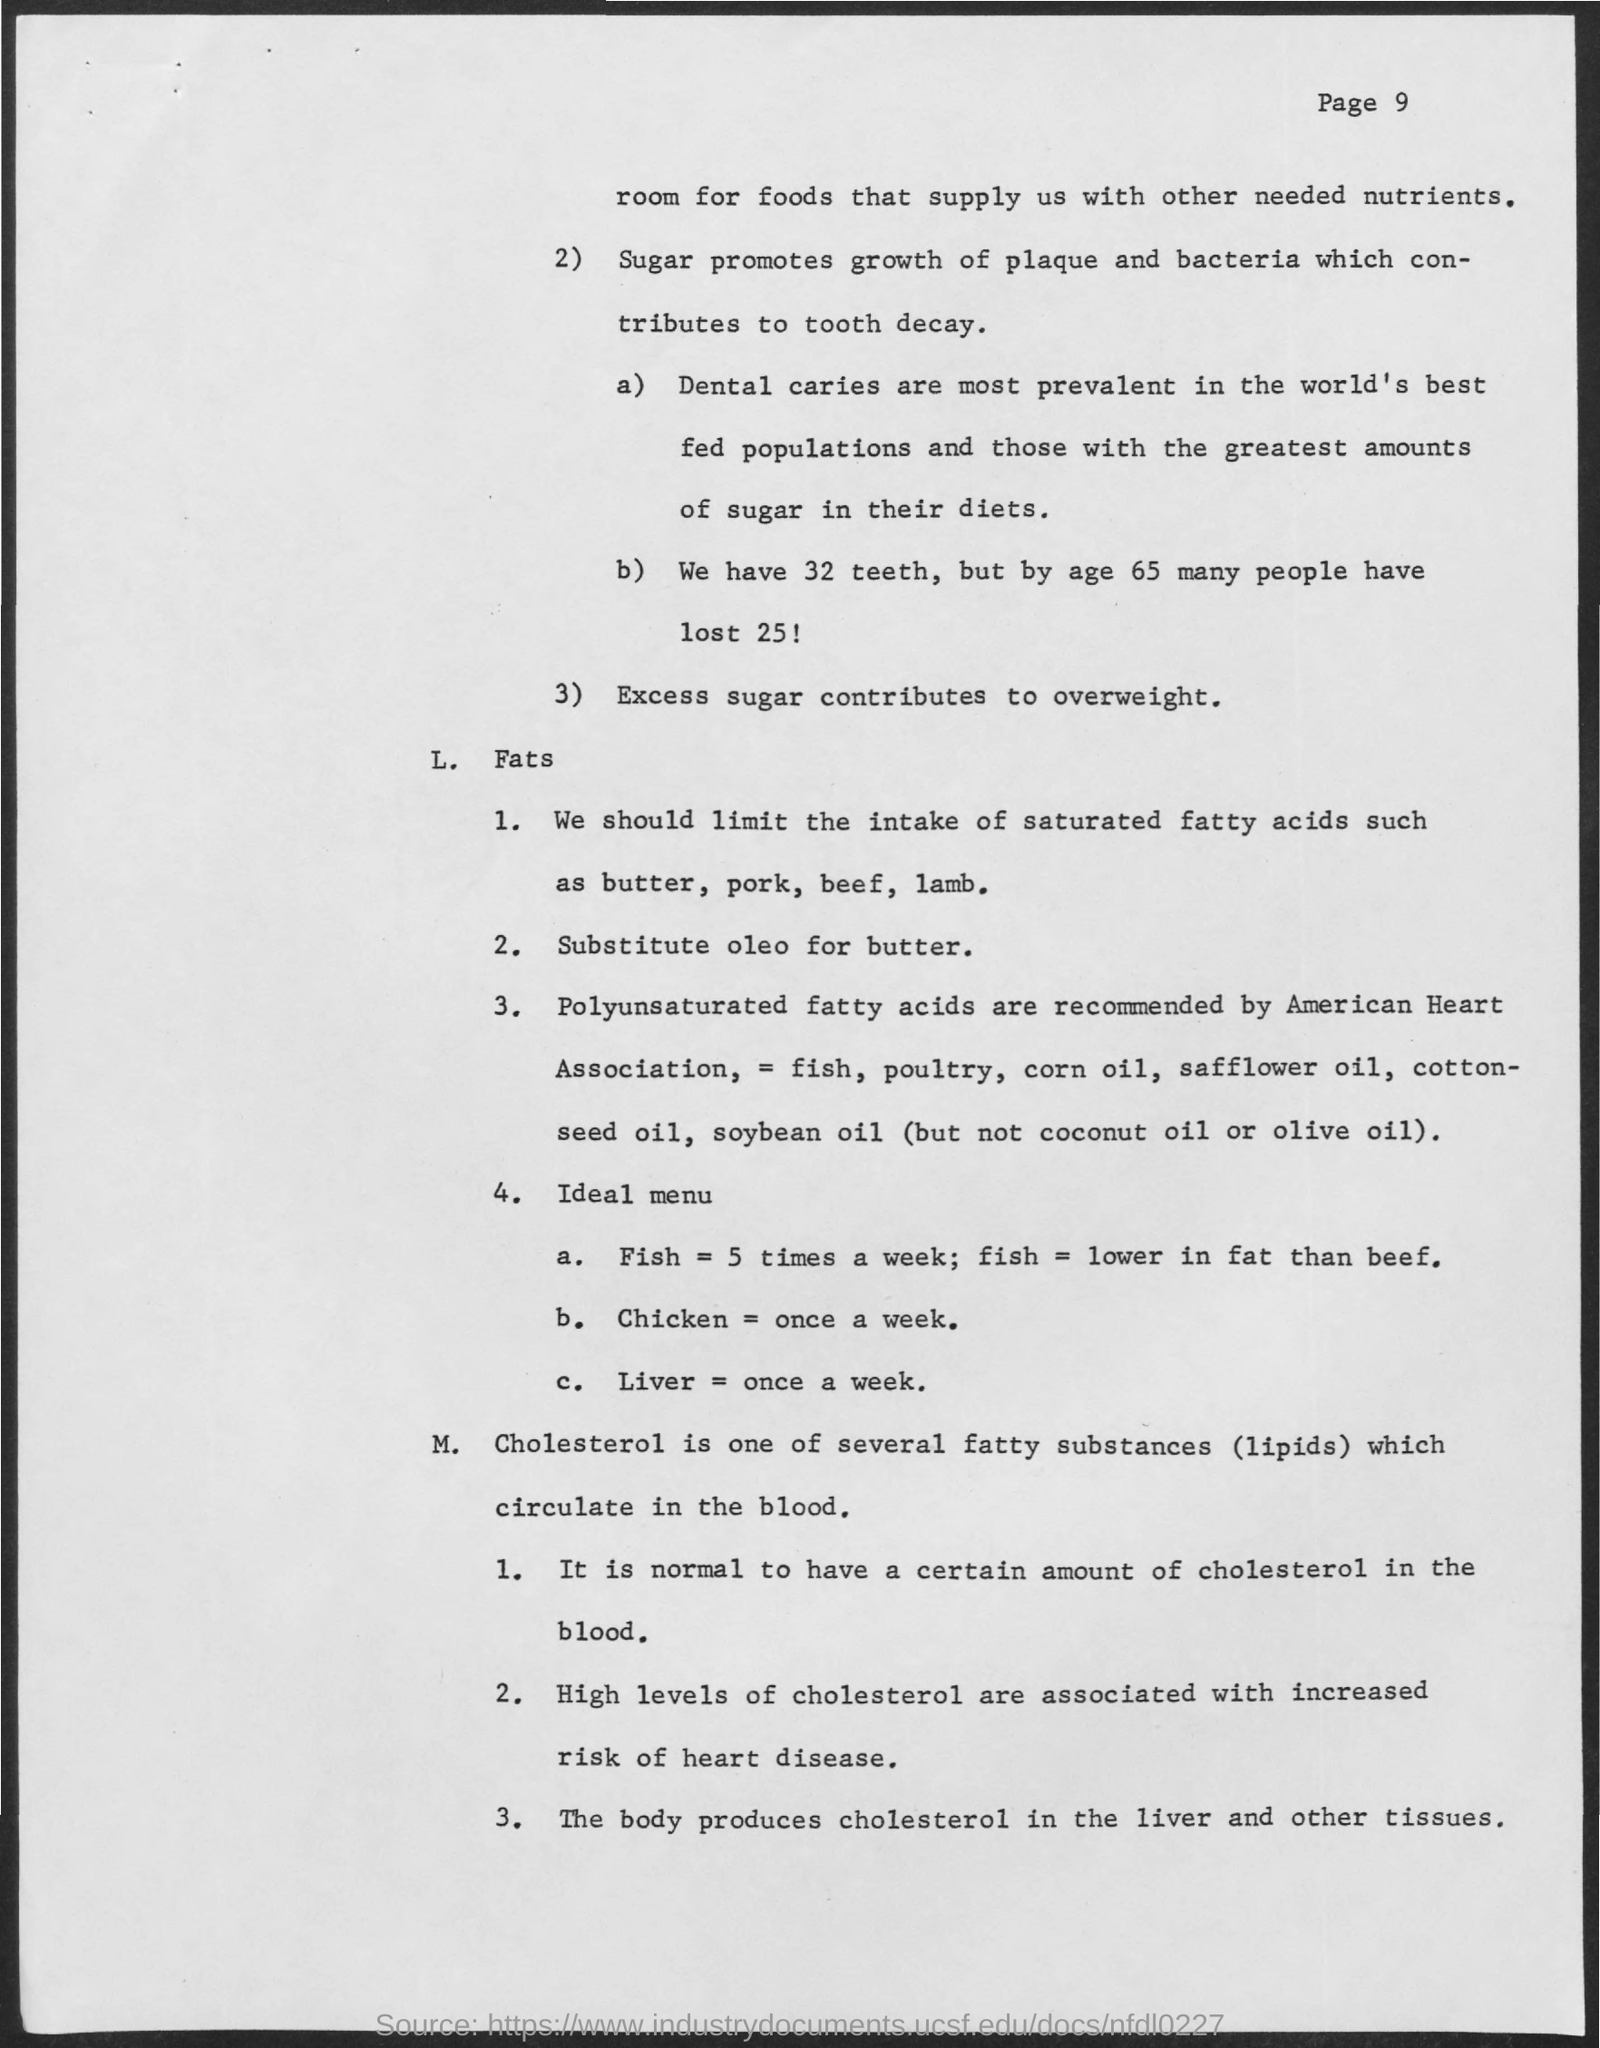Highlight a few significant elements in this photo. Cholesterol is one of several fatty substances (lipids) that circulate in the blood. The growth of plaque and bacteria, which leads to tooth decay, is primarily promoted by SUGAR. 